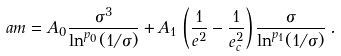Convert formula to latex. <formula><loc_0><loc_0><loc_500><loc_500>a m = A _ { 0 } \frac { \sigma ^ { 3 } } { \ln ^ { p _ { 0 } } ( 1 / \sigma ) } + A _ { 1 } \, \left ( \frac { 1 } { e ^ { 2 } } - \frac { 1 } { e _ { c } ^ { 2 } } \right ) \frac { \sigma } { \ln ^ { p _ { 1 } } ( 1 / \sigma ) } \, .</formula> 